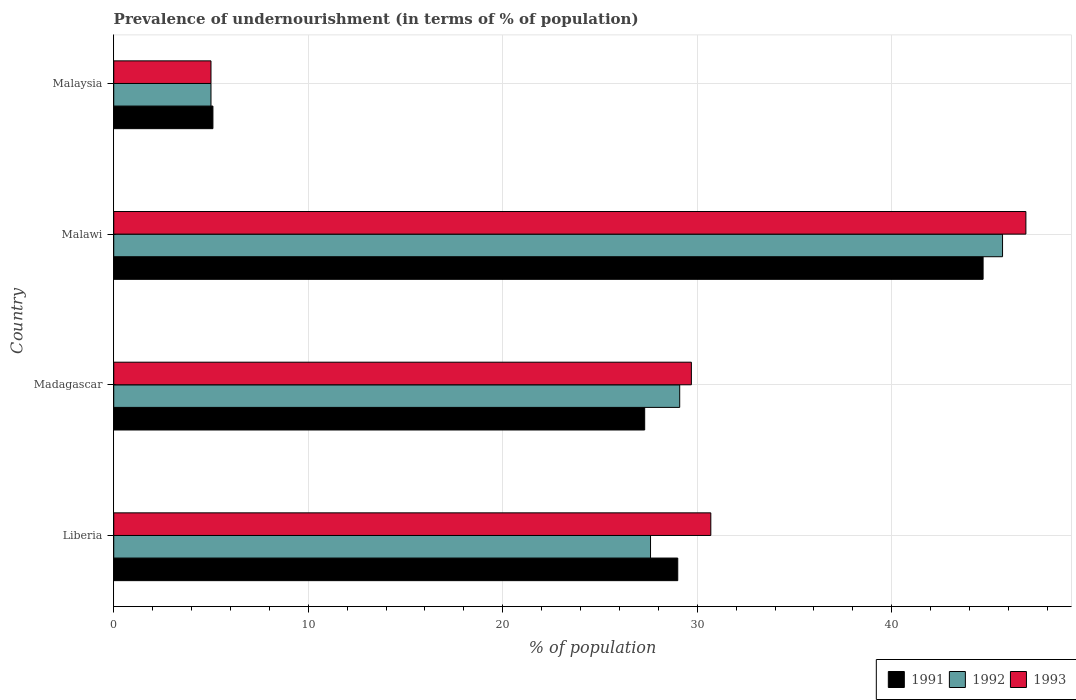Are the number of bars per tick equal to the number of legend labels?
Provide a short and direct response. Yes. How many bars are there on the 3rd tick from the bottom?
Provide a short and direct response. 3. What is the label of the 3rd group of bars from the top?
Provide a succinct answer. Madagascar. What is the percentage of undernourished population in 1991 in Madagascar?
Keep it short and to the point. 27.3. Across all countries, what is the maximum percentage of undernourished population in 1991?
Give a very brief answer. 44.7. In which country was the percentage of undernourished population in 1992 maximum?
Your answer should be very brief. Malawi. In which country was the percentage of undernourished population in 1992 minimum?
Offer a terse response. Malaysia. What is the total percentage of undernourished population in 1993 in the graph?
Give a very brief answer. 112.3. What is the difference between the percentage of undernourished population in 1991 in Liberia and that in Malaysia?
Give a very brief answer. 23.9. What is the difference between the percentage of undernourished population in 1992 in Malawi and the percentage of undernourished population in 1991 in Madagascar?
Your response must be concise. 18.4. What is the average percentage of undernourished population in 1992 per country?
Provide a short and direct response. 26.85. What is the difference between the percentage of undernourished population in 1992 and percentage of undernourished population in 1991 in Malawi?
Offer a very short reply. 1. What is the ratio of the percentage of undernourished population in 1991 in Madagascar to that in Malawi?
Provide a short and direct response. 0.61. What is the difference between the highest and the lowest percentage of undernourished population in 1993?
Your answer should be very brief. 41.9. What does the 2nd bar from the bottom in Malaysia represents?
Your answer should be compact. 1992. Is it the case that in every country, the sum of the percentage of undernourished population in 1993 and percentage of undernourished population in 1991 is greater than the percentage of undernourished population in 1992?
Your answer should be very brief. Yes. Are the values on the major ticks of X-axis written in scientific E-notation?
Provide a short and direct response. No. Does the graph contain grids?
Provide a short and direct response. Yes. Where does the legend appear in the graph?
Your answer should be compact. Bottom right. What is the title of the graph?
Offer a terse response. Prevalence of undernourishment (in terms of % of population). Does "2006" appear as one of the legend labels in the graph?
Offer a very short reply. No. What is the label or title of the X-axis?
Your answer should be very brief. % of population. What is the % of population of 1991 in Liberia?
Ensure brevity in your answer.  29. What is the % of population in 1992 in Liberia?
Give a very brief answer. 27.6. What is the % of population in 1993 in Liberia?
Offer a very short reply. 30.7. What is the % of population in 1991 in Madagascar?
Give a very brief answer. 27.3. What is the % of population of 1992 in Madagascar?
Provide a short and direct response. 29.1. What is the % of population of 1993 in Madagascar?
Give a very brief answer. 29.7. What is the % of population of 1991 in Malawi?
Give a very brief answer. 44.7. What is the % of population in 1992 in Malawi?
Make the answer very short. 45.7. What is the % of population in 1993 in Malawi?
Keep it short and to the point. 46.9. What is the % of population of 1993 in Malaysia?
Ensure brevity in your answer.  5. Across all countries, what is the maximum % of population of 1991?
Give a very brief answer. 44.7. Across all countries, what is the maximum % of population in 1992?
Offer a terse response. 45.7. Across all countries, what is the maximum % of population in 1993?
Give a very brief answer. 46.9. What is the total % of population in 1991 in the graph?
Make the answer very short. 106.1. What is the total % of population in 1992 in the graph?
Give a very brief answer. 107.4. What is the total % of population of 1993 in the graph?
Your answer should be compact. 112.3. What is the difference between the % of population in 1991 in Liberia and that in Madagascar?
Your response must be concise. 1.7. What is the difference between the % of population of 1992 in Liberia and that in Madagascar?
Provide a succinct answer. -1.5. What is the difference between the % of population in 1993 in Liberia and that in Madagascar?
Ensure brevity in your answer.  1. What is the difference between the % of population of 1991 in Liberia and that in Malawi?
Give a very brief answer. -15.7. What is the difference between the % of population of 1992 in Liberia and that in Malawi?
Provide a short and direct response. -18.1. What is the difference between the % of population of 1993 in Liberia and that in Malawi?
Ensure brevity in your answer.  -16.2. What is the difference between the % of population in 1991 in Liberia and that in Malaysia?
Offer a terse response. 23.9. What is the difference between the % of population of 1992 in Liberia and that in Malaysia?
Your answer should be very brief. 22.6. What is the difference between the % of population of 1993 in Liberia and that in Malaysia?
Provide a succinct answer. 25.7. What is the difference between the % of population of 1991 in Madagascar and that in Malawi?
Offer a very short reply. -17.4. What is the difference between the % of population of 1992 in Madagascar and that in Malawi?
Offer a very short reply. -16.6. What is the difference between the % of population of 1993 in Madagascar and that in Malawi?
Your response must be concise. -17.2. What is the difference between the % of population in 1992 in Madagascar and that in Malaysia?
Give a very brief answer. 24.1. What is the difference between the % of population in 1993 in Madagascar and that in Malaysia?
Your answer should be very brief. 24.7. What is the difference between the % of population of 1991 in Malawi and that in Malaysia?
Your answer should be very brief. 39.6. What is the difference between the % of population in 1992 in Malawi and that in Malaysia?
Offer a terse response. 40.7. What is the difference between the % of population of 1993 in Malawi and that in Malaysia?
Ensure brevity in your answer.  41.9. What is the difference between the % of population in 1991 in Liberia and the % of population in 1992 in Madagascar?
Your answer should be very brief. -0.1. What is the difference between the % of population of 1991 in Liberia and the % of population of 1993 in Madagascar?
Your answer should be compact. -0.7. What is the difference between the % of population in 1992 in Liberia and the % of population in 1993 in Madagascar?
Your response must be concise. -2.1. What is the difference between the % of population of 1991 in Liberia and the % of population of 1992 in Malawi?
Offer a very short reply. -16.7. What is the difference between the % of population in 1991 in Liberia and the % of population in 1993 in Malawi?
Offer a terse response. -17.9. What is the difference between the % of population in 1992 in Liberia and the % of population in 1993 in Malawi?
Provide a succinct answer. -19.3. What is the difference between the % of population in 1991 in Liberia and the % of population in 1993 in Malaysia?
Ensure brevity in your answer.  24. What is the difference between the % of population of 1992 in Liberia and the % of population of 1993 in Malaysia?
Give a very brief answer. 22.6. What is the difference between the % of population of 1991 in Madagascar and the % of population of 1992 in Malawi?
Offer a terse response. -18.4. What is the difference between the % of population of 1991 in Madagascar and the % of population of 1993 in Malawi?
Offer a terse response. -19.6. What is the difference between the % of population of 1992 in Madagascar and the % of population of 1993 in Malawi?
Keep it short and to the point. -17.8. What is the difference between the % of population of 1991 in Madagascar and the % of population of 1992 in Malaysia?
Keep it short and to the point. 22.3. What is the difference between the % of population of 1991 in Madagascar and the % of population of 1993 in Malaysia?
Provide a short and direct response. 22.3. What is the difference between the % of population in 1992 in Madagascar and the % of population in 1993 in Malaysia?
Ensure brevity in your answer.  24.1. What is the difference between the % of population of 1991 in Malawi and the % of population of 1992 in Malaysia?
Provide a succinct answer. 39.7. What is the difference between the % of population of 1991 in Malawi and the % of population of 1993 in Malaysia?
Your answer should be compact. 39.7. What is the difference between the % of population in 1992 in Malawi and the % of population in 1993 in Malaysia?
Your response must be concise. 40.7. What is the average % of population in 1991 per country?
Offer a very short reply. 26.52. What is the average % of population in 1992 per country?
Offer a terse response. 26.85. What is the average % of population in 1993 per country?
Your answer should be compact. 28.07. What is the difference between the % of population in 1991 and % of population in 1992 in Liberia?
Ensure brevity in your answer.  1.4. What is the difference between the % of population of 1991 and % of population of 1993 in Liberia?
Keep it short and to the point. -1.7. What is the difference between the % of population in 1991 and % of population in 1992 in Madagascar?
Ensure brevity in your answer.  -1.8. What is the difference between the % of population of 1991 and % of population of 1992 in Malawi?
Ensure brevity in your answer.  -1. What is the difference between the % of population in 1991 and % of population in 1993 in Malawi?
Your answer should be compact. -2.2. What is the difference between the % of population in 1991 and % of population in 1992 in Malaysia?
Offer a terse response. 0.1. What is the difference between the % of population in 1991 and % of population in 1993 in Malaysia?
Offer a terse response. 0.1. What is the ratio of the % of population in 1991 in Liberia to that in Madagascar?
Offer a very short reply. 1.06. What is the ratio of the % of population in 1992 in Liberia to that in Madagascar?
Make the answer very short. 0.95. What is the ratio of the % of population in 1993 in Liberia to that in Madagascar?
Make the answer very short. 1.03. What is the ratio of the % of population in 1991 in Liberia to that in Malawi?
Make the answer very short. 0.65. What is the ratio of the % of population in 1992 in Liberia to that in Malawi?
Your answer should be compact. 0.6. What is the ratio of the % of population of 1993 in Liberia to that in Malawi?
Your answer should be compact. 0.65. What is the ratio of the % of population in 1991 in Liberia to that in Malaysia?
Your answer should be very brief. 5.69. What is the ratio of the % of population of 1992 in Liberia to that in Malaysia?
Offer a terse response. 5.52. What is the ratio of the % of population of 1993 in Liberia to that in Malaysia?
Your response must be concise. 6.14. What is the ratio of the % of population of 1991 in Madagascar to that in Malawi?
Give a very brief answer. 0.61. What is the ratio of the % of population of 1992 in Madagascar to that in Malawi?
Provide a succinct answer. 0.64. What is the ratio of the % of population in 1993 in Madagascar to that in Malawi?
Provide a short and direct response. 0.63. What is the ratio of the % of population of 1991 in Madagascar to that in Malaysia?
Your answer should be very brief. 5.35. What is the ratio of the % of population in 1992 in Madagascar to that in Malaysia?
Make the answer very short. 5.82. What is the ratio of the % of population in 1993 in Madagascar to that in Malaysia?
Offer a terse response. 5.94. What is the ratio of the % of population of 1991 in Malawi to that in Malaysia?
Provide a succinct answer. 8.76. What is the ratio of the % of population of 1992 in Malawi to that in Malaysia?
Offer a very short reply. 9.14. What is the ratio of the % of population in 1993 in Malawi to that in Malaysia?
Give a very brief answer. 9.38. What is the difference between the highest and the second highest % of population in 1991?
Make the answer very short. 15.7. What is the difference between the highest and the second highest % of population of 1993?
Make the answer very short. 16.2. What is the difference between the highest and the lowest % of population in 1991?
Provide a short and direct response. 39.6. What is the difference between the highest and the lowest % of population of 1992?
Keep it short and to the point. 40.7. What is the difference between the highest and the lowest % of population of 1993?
Make the answer very short. 41.9. 